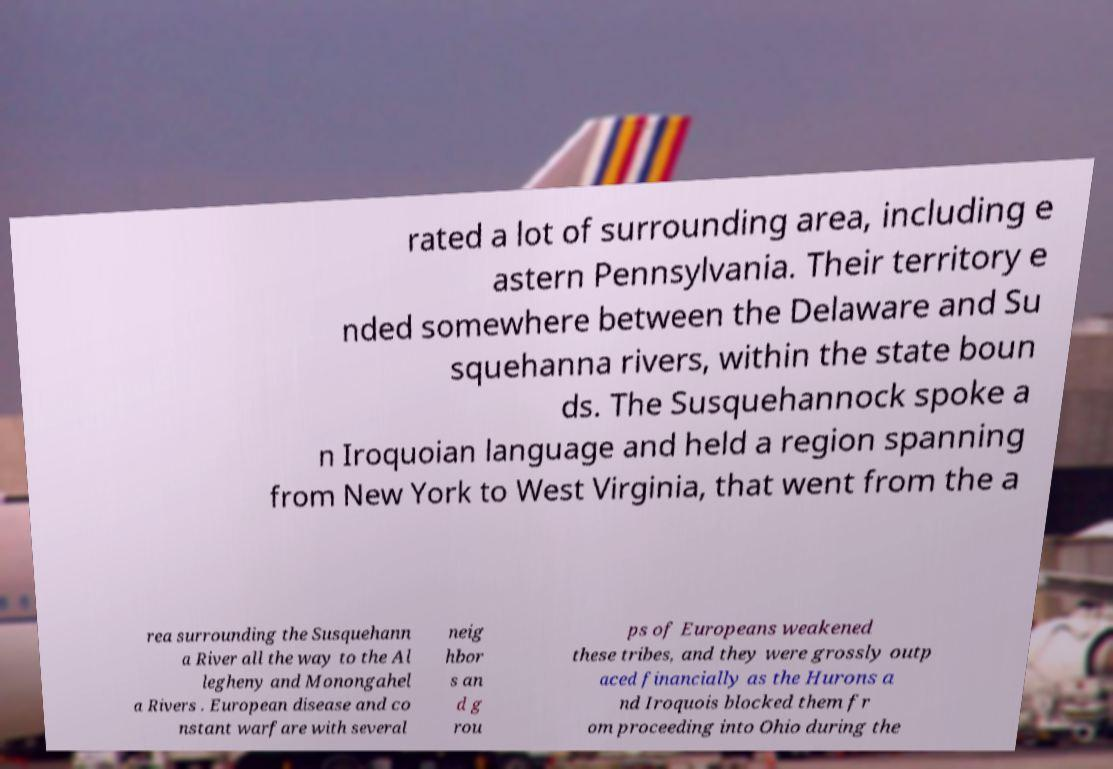Please read and relay the text visible in this image. What does it say? rated a lot of surrounding area, including e astern Pennsylvania. Their territory e nded somewhere between the Delaware and Su squehanna rivers, within the state boun ds. The Susquehannock spoke a n Iroquoian language and held a region spanning from New York to West Virginia, that went from the a rea surrounding the Susquehann a River all the way to the Al legheny and Monongahel a Rivers . European disease and co nstant warfare with several neig hbor s an d g rou ps of Europeans weakened these tribes, and they were grossly outp aced financially as the Hurons a nd Iroquois blocked them fr om proceeding into Ohio during the 